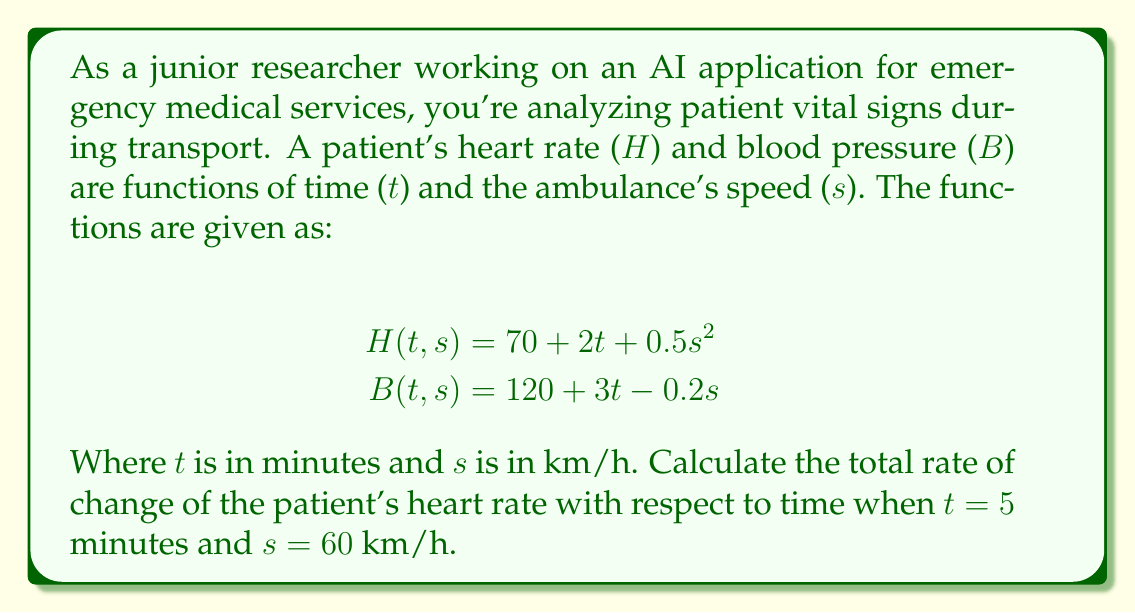Provide a solution to this math problem. To solve this problem, we need to use the concept of total derivative from multivariable calculus. The total rate of change of heart rate with respect to time is given by the total derivative:

$$\frac{dH}{dt} = \frac{\partial H}{\partial t} + \frac{\partial H}{\partial s} \cdot \frac{ds}{dt}$$

Let's break this down step-by-step:

1) First, we need to calculate $\frac{\partial H}{\partial t}$:
   $$\frac{\partial H}{\partial t} = 2$$

2) Next, we calculate $\frac{\partial H}{\partial s}$:
   $$\frac{\partial H}{\partial s} = s$$

3) We need to find $\frac{ds}{dt}$. This represents how the ambulance's speed changes with time. However, this information is not given in the problem. Let's assume it's constant and denote it as $a$ (acceleration).

4) Now we can write our total derivative:
   $$\frac{dH}{dt} = 2 + s \cdot a$$

5) We're asked to evaluate this when t = 5 and s = 60. Substituting these values:
   $$\frac{dH}{dt} = 2 + 60a$$

6) The final answer depends on the value of $a$. If we assume the ambulance is moving at a constant speed (a = 0), then:
   $$\frac{dH}{dt} = 2$$

This means the heart rate is increasing by 2 beats per minute each minute, regardless of the ambulance's speed (when the speed is constant).
Answer: $2 + 60a$ beats/min², where $a$ is the ambulance's acceleration in km/h/min 